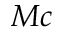<formula> <loc_0><loc_0><loc_500><loc_500>M c</formula> 